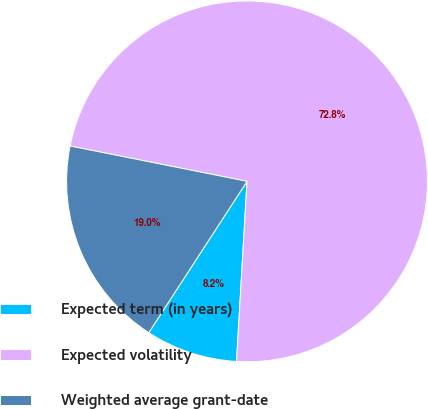<chart> <loc_0><loc_0><loc_500><loc_500><pie_chart><fcel>Expected term (in years)<fcel>Expected volatility<fcel>Weighted average grant-date<nl><fcel>8.24%<fcel>72.78%<fcel>18.97%<nl></chart> 